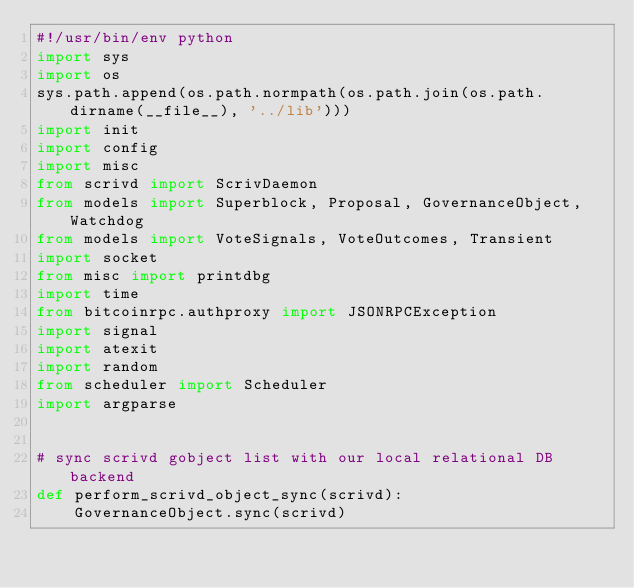Convert code to text. <code><loc_0><loc_0><loc_500><loc_500><_Python_>#!/usr/bin/env python
import sys
import os
sys.path.append(os.path.normpath(os.path.join(os.path.dirname(__file__), '../lib')))
import init
import config
import misc
from scrivd import ScrivDaemon
from models import Superblock, Proposal, GovernanceObject, Watchdog
from models import VoteSignals, VoteOutcomes, Transient
import socket
from misc import printdbg
import time
from bitcoinrpc.authproxy import JSONRPCException
import signal
import atexit
import random
from scheduler import Scheduler
import argparse


# sync scrivd gobject list with our local relational DB backend
def perform_scrivd_object_sync(scrivd):
    GovernanceObject.sync(scrivd)

</code> 